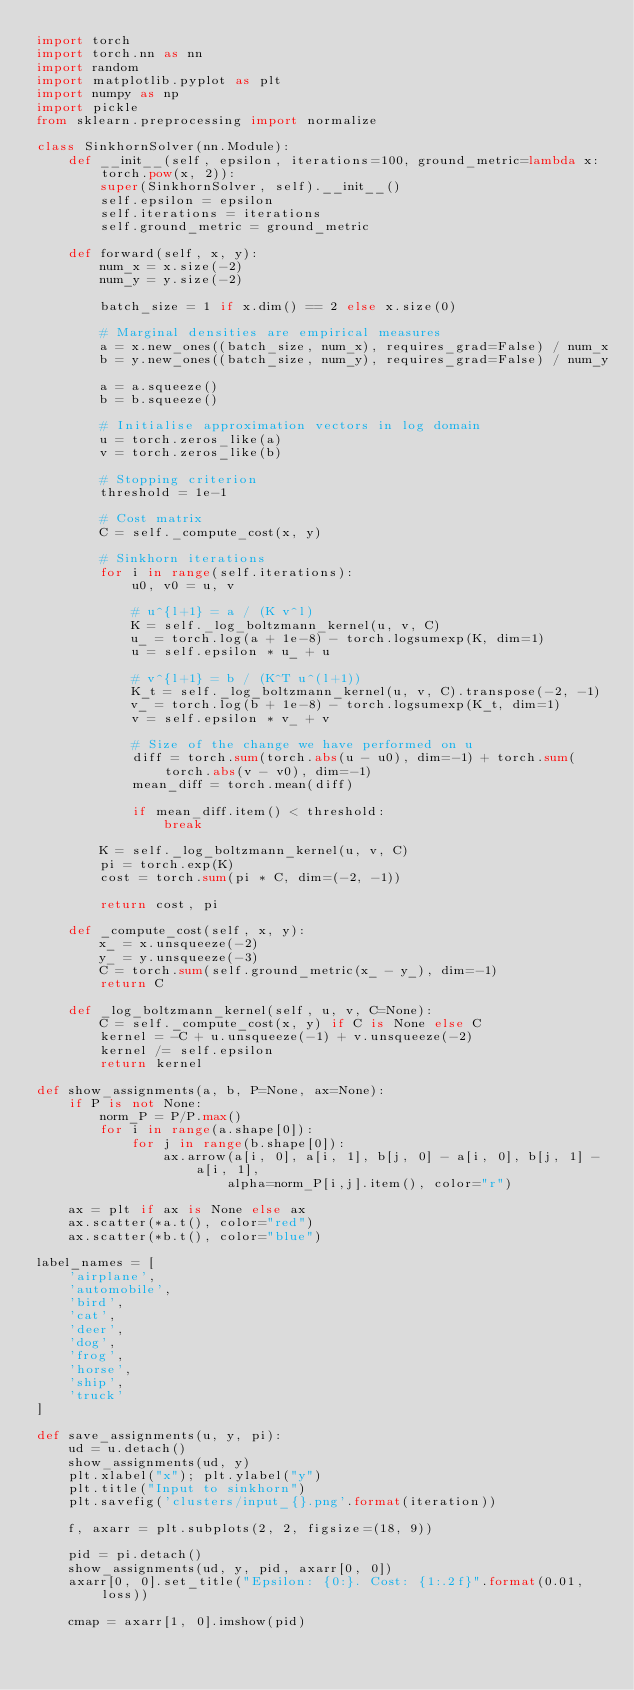Convert code to text. <code><loc_0><loc_0><loc_500><loc_500><_Python_>import torch
import torch.nn as nn
import random
import matplotlib.pyplot as plt
import numpy as np
import pickle
from sklearn.preprocessing import normalize

class SinkhornSolver(nn.Module):
    def __init__(self, epsilon, iterations=100, ground_metric=lambda x: torch.pow(x, 2)):
        super(SinkhornSolver, self).__init__()
        self.epsilon = epsilon
        self.iterations = iterations
        self.ground_metric = ground_metric

    def forward(self, x, y):
        num_x = x.size(-2)
        num_y = y.size(-2)
        
        batch_size = 1 if x.dim() == 2 else x.size(0)

        # Marginal densities are empirical measures
        a = x.new_ones((batch_size, num_x), requires_grad=False) / num_x
        b = y.new_ones((batch_size, num_y), requires_grad=False) / num_y
        
        a = a.squeeze()
        b = b.squeeze()
                
        # Initialise approximation vectors in log domain
        u = torch.zeros_like(a)
        v = torch.zeros_like(b)

        # Stopping criterion
        threshold = 1e-1
        
        # Cost matrix
        C = self._compute_cost(x, y)

        # Sinkhorn iterations
        for i in range(self.iterations): 
            u0, v0 = u, v
                        
            # u^{l+1} = a / (K v^l)
            K = self._log_boltzmann_kernel(u, v, C)
            u_ = torch.log(a + 1e-8) - torch.logsumexp(K, dim=1)
            u = self.epsilon * u_ + u
                        
            # v^{l+1} = b / (K^T u^(l+1))
            K_t = self._log_boltzmann_kernel(u, v, C).transpose(-2, -1)
            v_ = torch.log(b + 1e-8) - torch.logsumexp(K_t, dim=1)
            v = self.epsilon * v_ + v
            
            # Size of the change we have performed on u
            diff = torch.sum(torch.abs(u - u0), dim=-1) + torch.sum(torch.abs(v - v0), dim=-1)
            mean_diff = torch.mean(diff)
                        
            if mean_diff.item() < threshold:
                break

        K = self._log_boltzmann_kernel(u, v, C)
        pi = torch.exp(K)
        cost = torch.sum(pi * C, dim=(-2, -1))

        return cost, pi

    def _compute_cost(self, x, y):
        x_ = x.unsqueeze(-2)
        y_ = y.unsqueeze(-3)
        C = torch.sum(self.ground_metric(x_ - y_), dim=-1)
        return C

    def _log_boltzmann_kernel(self, u, v, C=None):
        C = self._compute_cost(x, y) if C is None else C
        kernel = -C + u.unsqueeze(-1) + v.unsqueeze(-2)
        kernel /= self.epsilon
        return kernel

def show_assignments(a, b, P=None, ax=None): 
    if P is not None:
        norm_P = P/P.max()
        for i in range(a.shape[0]):
            for j in range(b.shape[0]):
                ax.arrow(a[i, 0], a[i, 1], b[j, 0] - a[i, 0], b[j, 1] - a[i, 1],
                        alpha=norm_P[i,j].item(), color="r")

    ax = plt if ax is None else ax
    ax.scatter(*a.t(), color="red")
    ax.scatter(*b.t(), color="blue")

label_names = [
    'airplane',
    'automobile',
    'bird',
    'cat',
    'deer',
    'dog',
    'frog',
    'horse',
    'ship',
    'truck'
]

def save_assignments(u, y, pi):
    ud = u.detach()
    show_assignments(ud, y)
    plt.xlabel("x"); plt.ylabel("y")
    plt.title("Input to sinkhorn")
    plt.savefig('clusters/input_{}.png'.format(iteration))

    f, axarr = plt.subplots(2, 2, figsize=(18, 9))

    pid = pi.detach()
    show_assignments(ud, y, pid, axarr[0, 0])
    axarr[0, 0].set_title("Epsilon: {0:}. Cost: {1:.2f}".format(0.01, loss))

    cmap = axarr[1, 0].imshow(pid)</code> 